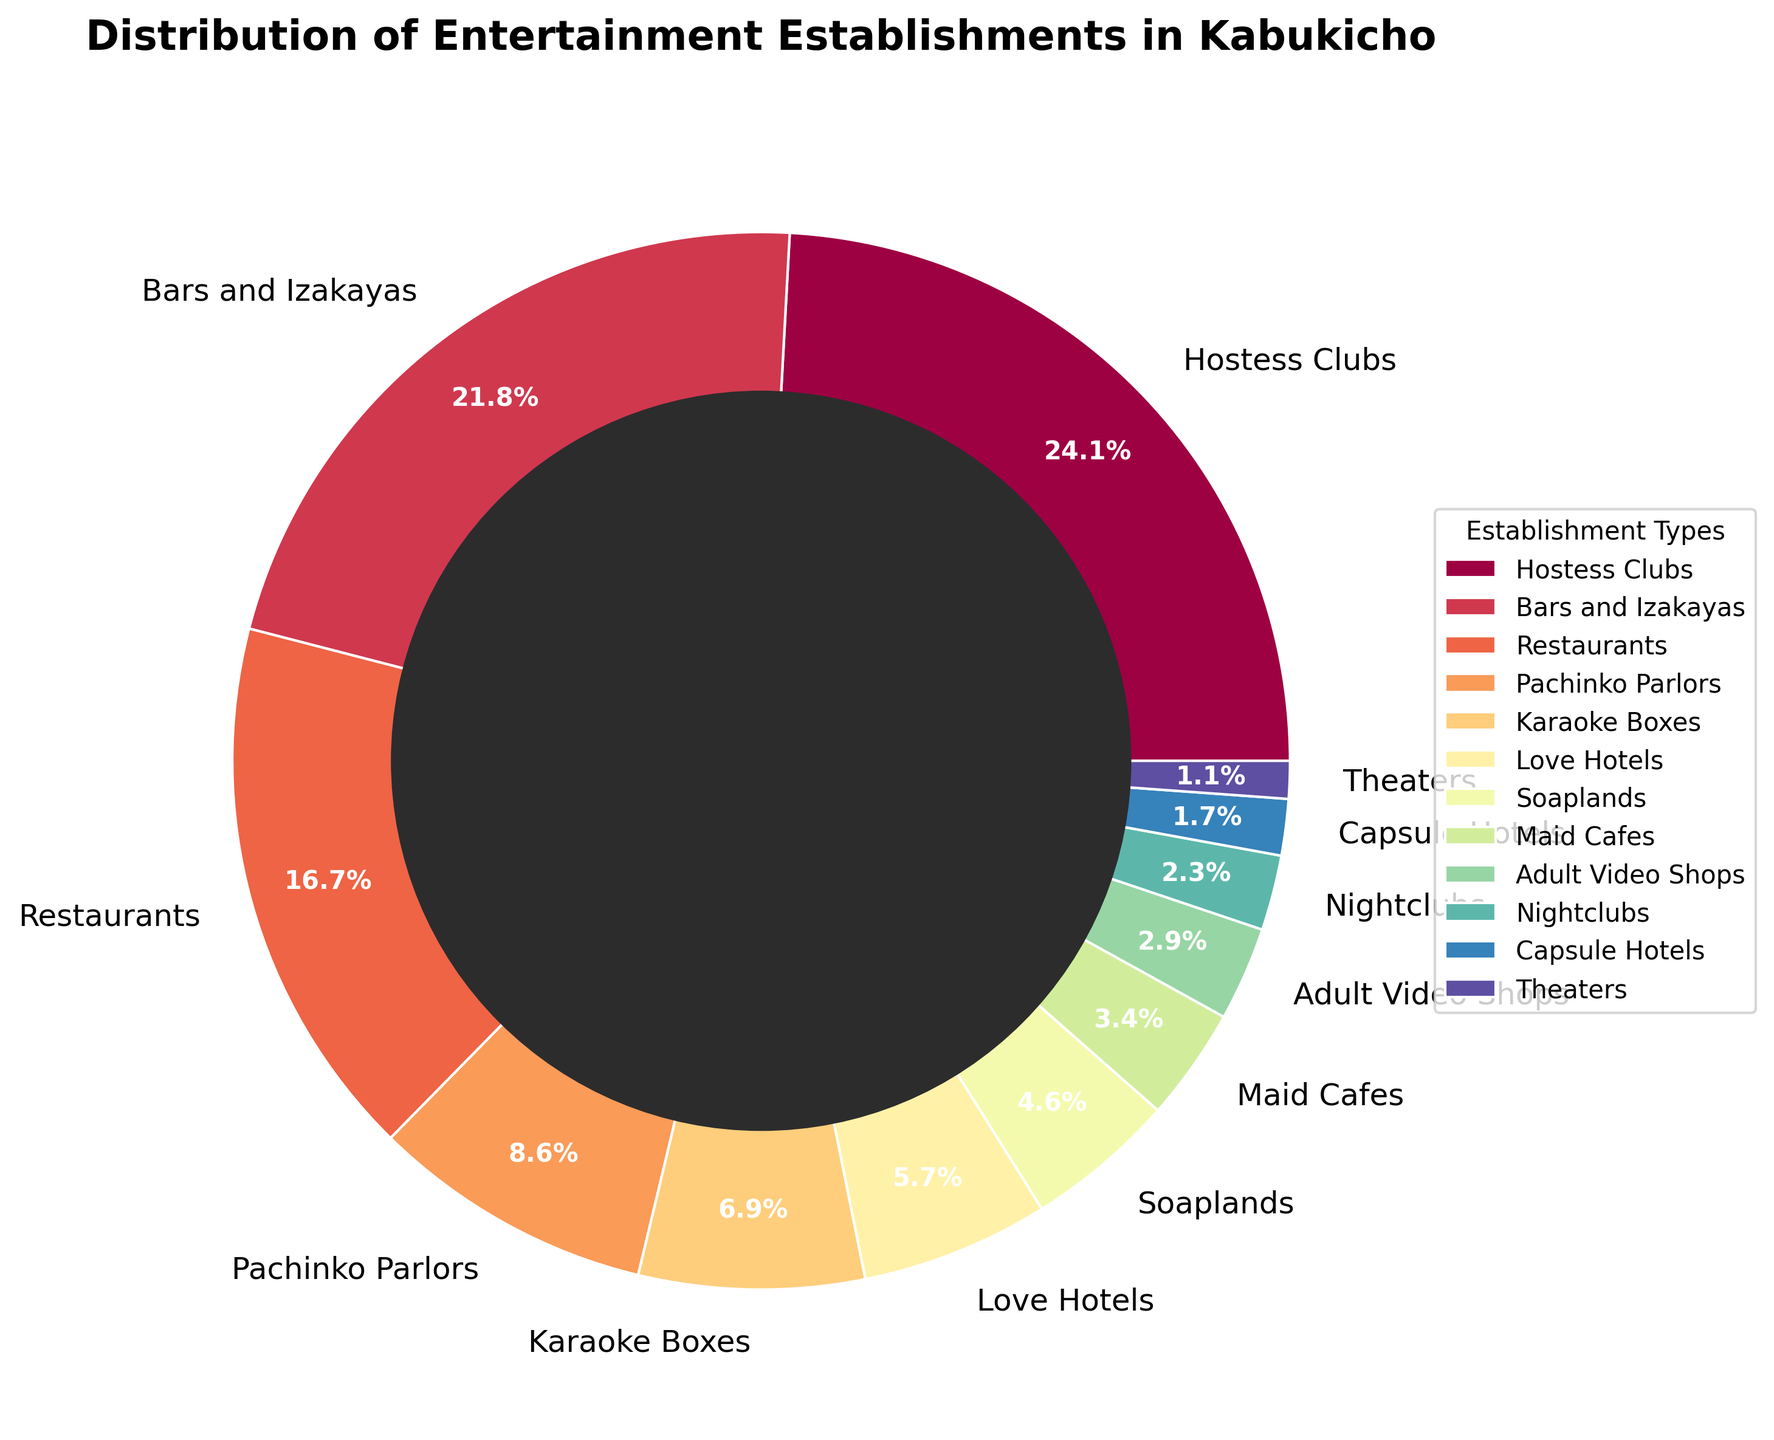What's the most common type of entertainment establishment in Kabukicho? The most common type of entertainment establishment can be seen as the largest segment in the pie chart. The segment for "Hostess Clubs" is the largest, indicating it is the most common type.
Answer: Hostess Clubs Which type of establishment is more prevalent, bars and izakayas or restaurants? To determine which is more prevalent, compare the sizes of the segments for "Bars and Izakayas" and "Restaurants." The segment for "Bars and Izakayas" is larger.
Answer: Bars and Izakayas Are there more karaoke boxes or pachinko parlors in Kabukicho? Compare the sizes of the segments for "Karaoke Boxes" and "Pachinko Parlors." The segment for "Pachinko Parlors" is larger.
Answer: Pachinko Parlors What's the combined percentage of karaoke boxes and maid cafes? Locate the percentages for "Karaoke Boxes" and "Maid Cafes" on the pie chart. Adding the two percentages: 12% (Karaoke Boxes) + 6% (Maid Cafes) = 18%.
Answer: 18% Which establishments have the smallest representation on the pie chart? Look for the smallest segments on the pie chart. "Theaters" and "Capsule Hotels" are the smallest segments.
Answer: Theaters and Capsule Hotels Are there fewer love hotels or adult video shops? Compare the sizes of the segments. The segment for "Love Hotels" is larger than that for "Adult Video Shops."
Answer: Adult Video Shops What's the percentage difference between hostess clubs and karaoke boxes? Find and subtract the percentages for "Hostess Clubs" and "Karaoke Boxes." Suppose "Hostess Clubs" is 42% and "Karaoke Boxes" is 12%; 42% - 12% = 30%.
Answer: 30% Which establishments combined make up less than 10% of the total? Check the chart for segments with percentages adding up to less than 10%. "Nightclubs" (4%) + "Capsule Hotels" (3%) make up less than 10%.
Answer: Nightclubs and Capsule Hotels 